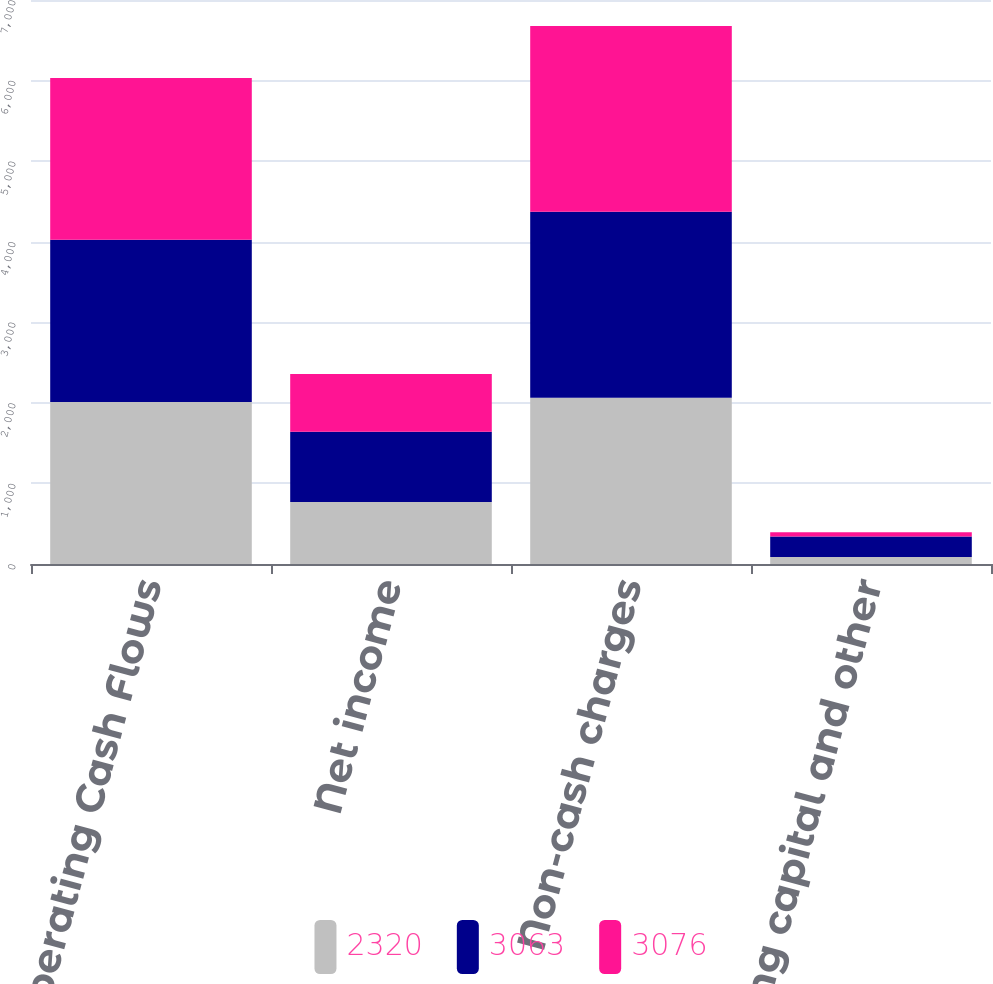<chart> <loc_0><loc_0><loc_500><loc_500><stacked_bar_chart><ecel><fcel>Operating Cash Flows<fcel>Net income<fcel>Non-cash charges<fcel>Working capital and other<nl><fcel>2320<fcel>2012<fcel>771<fcel>2063<fcel>86<nl><fcel>3063<fcel>2011<fcel>869<fcel>2310<fcel>256<nl><fcel>3076<fcel>2010<fcel>718<fcel>2305<fcel>53<nl></chart> 